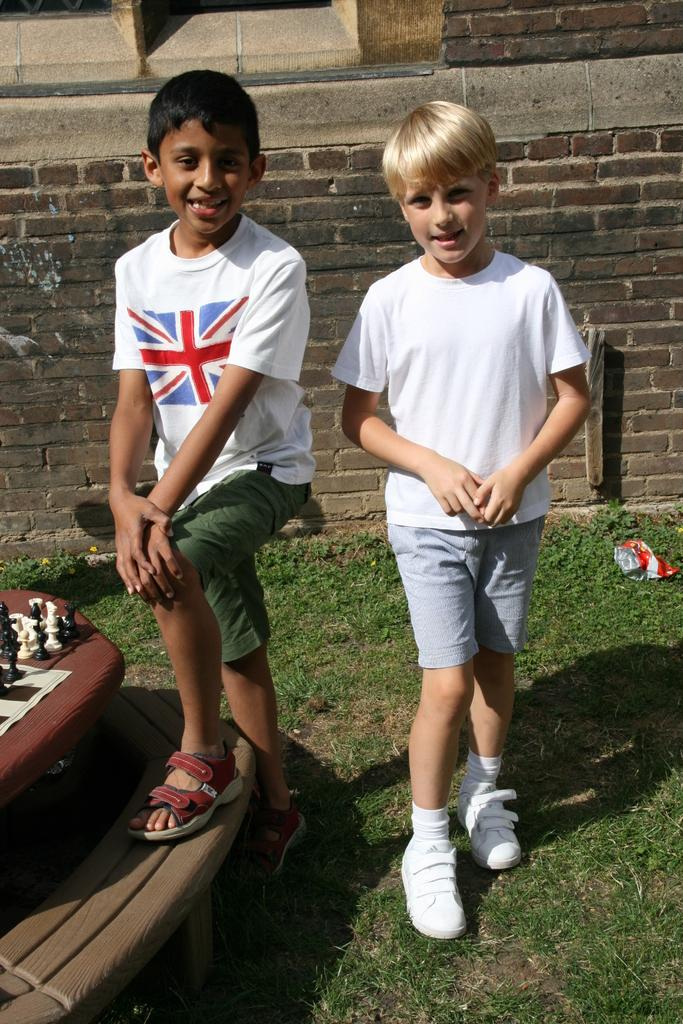How many boys are in the image? There are two boys in the foreground of the image. What are the boys doing in the image? The boys are on the ground in the foreground of the image. What object is visible in the foreground of the image? There is a chess board in the foreground of the image. What can be seen in the background of the image? There is a wall of bricks and a window in the background of the image. Where was the image taken? The image was taken on the ground. What type of spoon can be seen floating in the river in the image? There is no spoon or river present in the image; it features two boys on the ground with a chess board in the foreground and a wall of bricks and a window in the background. 